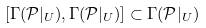Convert formula to latex. <formula><loc_0><loc_0><loc_500><loc_500>[ \Gamma ( \mathcal { P } | _ { U } ) , \Gamma ( \mathcal { P } | _ { U } ) ] \subset \Gamma ( \mathcal { P } | _ { U } )</formula> 